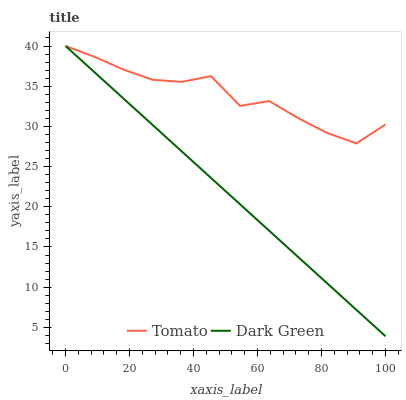Does Dark Green have the maximum area under the curve?
Answer yes or no. No. Is Dark Green the roughest?
Answer yes or no. No. 